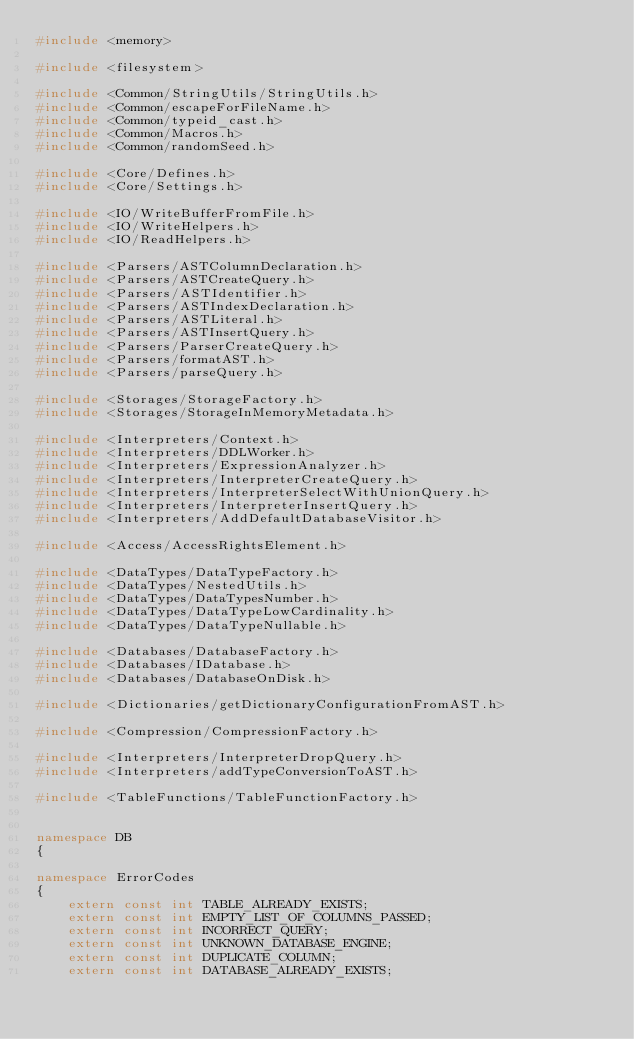Convert code to text. <code><loc_0><loc_0><loc_500><loc_500><_C++_>#include <memory>

#include <filesystem>

#include <Common/StringUtils/StringUtils.h>
#include <Common/escapeForFileName.h>
#include <Common/typeid_cast.h>
#include <Common/Macros.h>
#include <Common/randomSeed.h>

#include <Core/Defines.h>
#include <Core/Settings.h>

#include <IO/WriteBufferFromFile.h>
#include <IO/WriteHelpers.h>
#include <IO/ReadHelpers.h>

#include <Parsers/ASTColumnDeclaration.h>
#include <Parsers/ASTCreateQuery.h>
#include <Parsers/ASTIdentifier.h>
#include <Parsers/ASTIndexDeclaration.h>
#include <Parsers/ASTLiteral.h>
#include <Parsers/ASTInsertQuery.h>
#include <Parsers/ParserCreateQuery.h>
#include <Parsers/formatAST.h>
#include <Parsers/parseQuery.h>

#include <Storages/StorageFactory.h>
#include <Storages/StorageInMemoryMetadata.h>

#include <Interpreters/Context.h>
#include <Interpreters/DDLWorker.h>
#include <Interpreters/ExpressionAnalyzer.h>
#include <Interpreters/InterpreterCreateQuery.h>
#include <Interpreters/InterpreterSelectWithUnionQuery.h>
#include <Interpreters/InterpreterInsertQuery.h>
#include <Interpreters/AddDefaultDatabaseVisitor.h>

#include <Access/AccessRightsElement.h>

#include <DataTypes/DataTypeFactory.h>
#include <DataTypes/NestedUtils.h>
#include <DataTypes/DataTypesNumber.h>
#include <DataTypes/DataTypeLowCardinality.h>
#include <DataTypes/DataTypeNullable.h>

#include <Databases/DatabaseFactory.h>
#include <Databases/IDatabase.h>
#include <Databases/DatabaseOnDisk.h>

#include <Dictionaries/getDictionaryConfigurationFromAST.h>

#include <Compression/CompressionFactory.h>

#include <Interpreters/InterpreterDropQuery.h>
#include <Interpreters/addTypeConversionToAST.h>

#include <TableFunctions/TableFunctionFactory.h>


namespace DB
{

namespace ErrorCodes
{
    extern const int TABLE_ALREADY_EXISTS;
    extern const int EMPTY_LIST_OF_COLUMNS_PASSED;
    extern const int INCORRECT_QUERY;
    extern const int UNKNOWN_DATABASE_ENGINE;
    extern const int DUPLICATE_COLUMN;
    extern const int DATABASE_ALREADY_EXISTS;</code> 